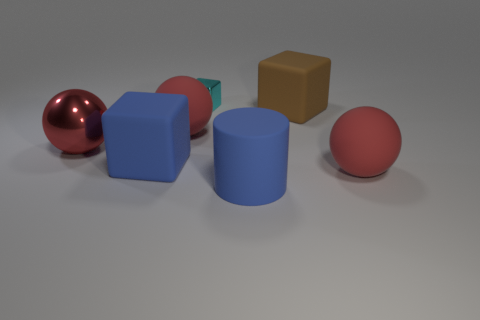How many red balls must be subtracted to get 1 red balls? 2 Add 2 tiny cyan things. How many objects exist? 9 Subtract all blocks. How many objects are left? 4 Subtract all blue matte balls. Subtract all big cylinders. How many objects are left? 6 Add 3 red balls. How many red balls are left? 6 Add 4 red things. How many red things exist? 7 Subtract 0 green blocks. How many objects are left? 7 